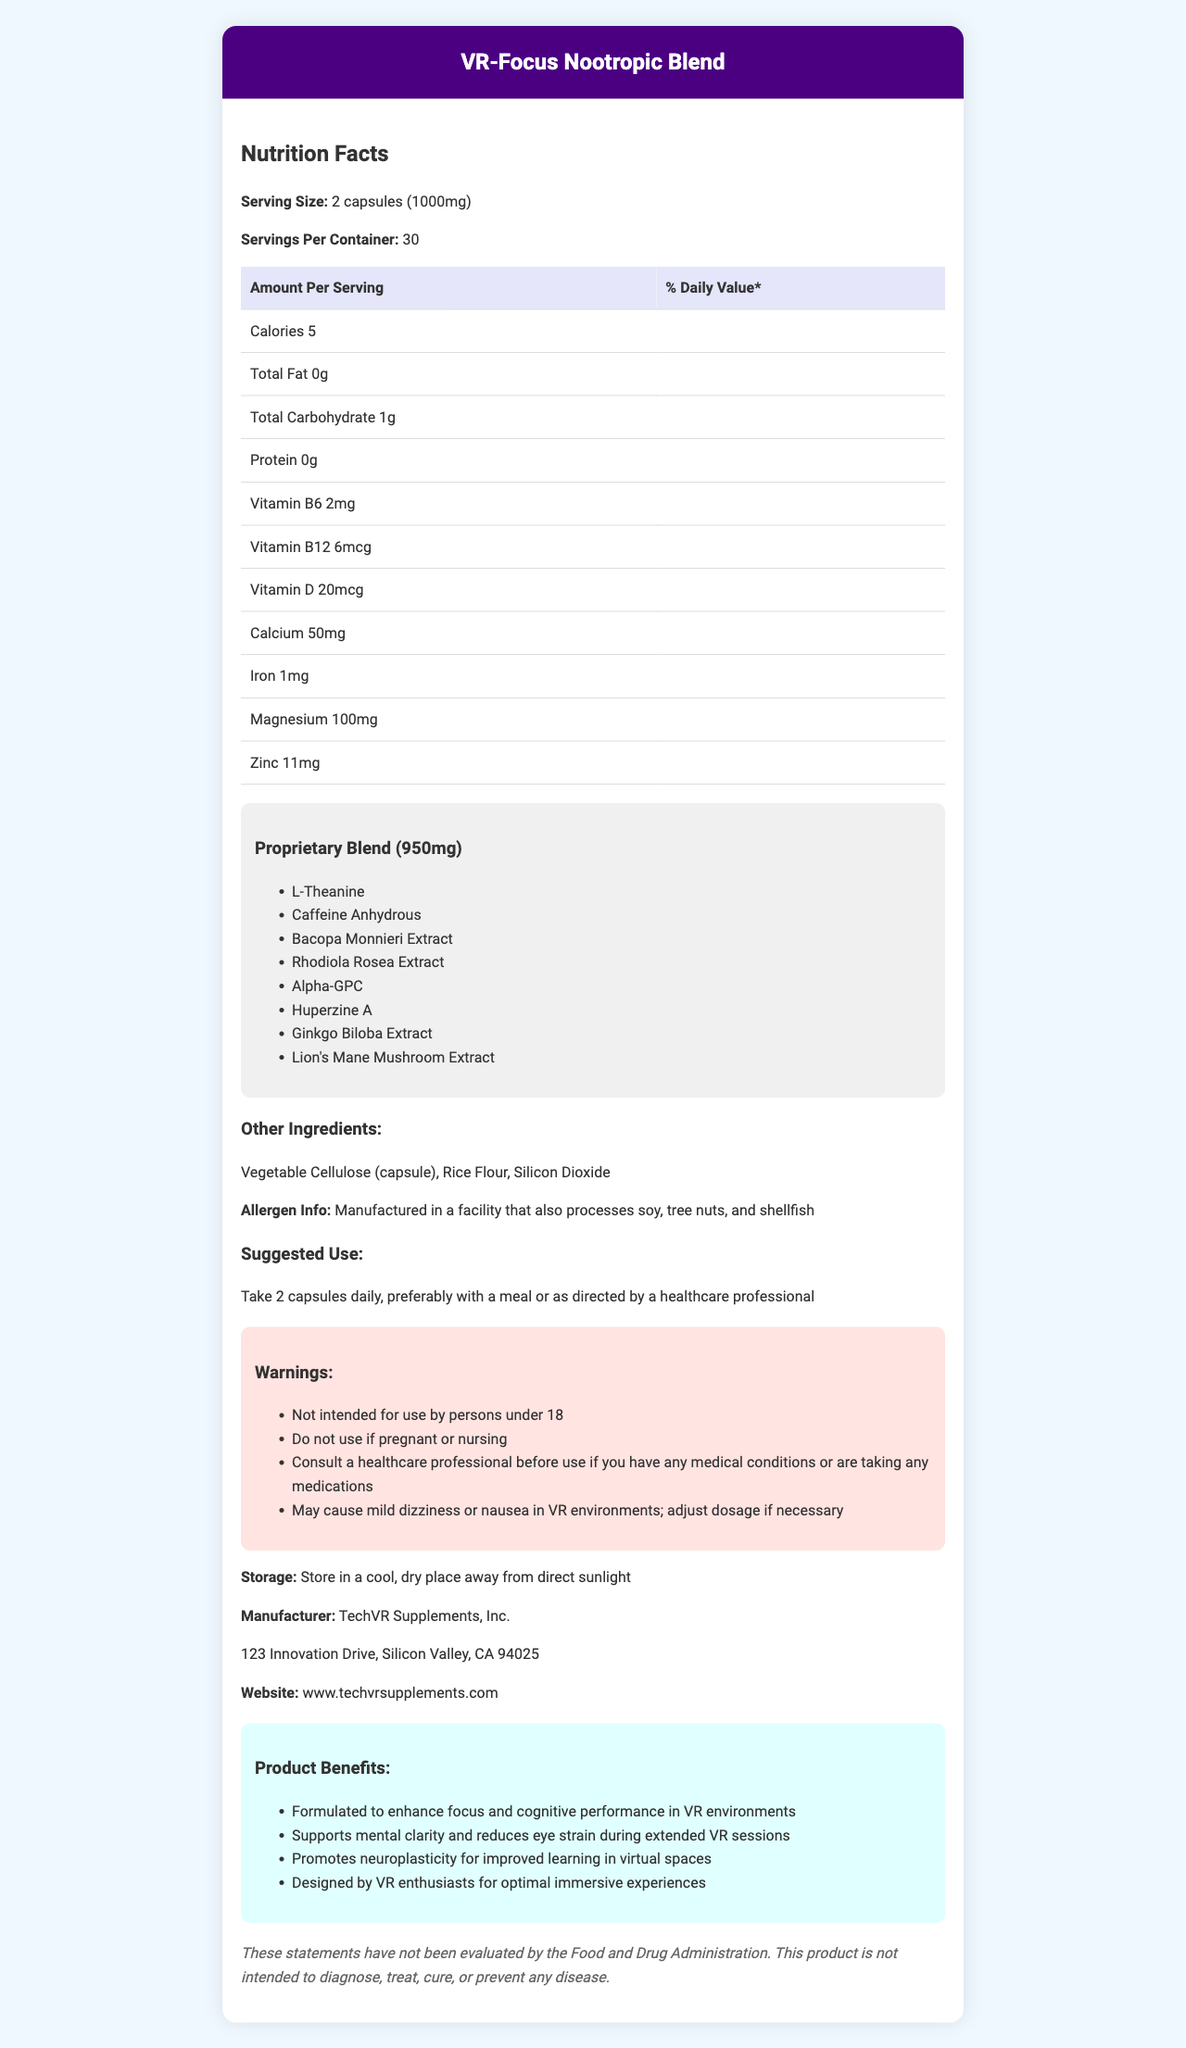What is the serving size for VR-Focus Nootropic Blend? The serving size is clearly mentioned in the document as "2 capsules (1000mg)".
Answer: 2 capsules (1000mg) How many calories are in each serving? The document indicates that each serving contains 5 calories.
Answer: 5 calories What are the suggested use instructions for VR-Focus Nootropic Blend? The suggested use is stated in the document under "Suggested Use".
Answer: Take 2 capsules daily, preferably with a meal or as directed by a healthcare professional Which vitamins are included in the supplement? The document lists Vitamin B6, Vitamin B12, and Vitamin D in the nutrition facts.
Answer: Vitamin B6, Vitamin B12, Vitamin D How much magnesium is in each serving? The document specifies that there is 100mg of magnesium per serving.
Answer: 100mg Which of the following ingredients is NOT part of the proprietary blend? A. L-Theanine B. Rice Flour C. Alpha-GPC D. Bacopa Monnieri Extract The proprietary blend includes L-Theanine, Alpha-GPC, and Bacopa Monnieri Extract. Rice Flour is listed under "Other Ingredients".
Answer: B. Rice Flour What is the percentage daily value of zinc per serving, if the daily value for zinc is 11mg? A. 50% B. 75% C. 100% D. 200% The per serving amount of Zinc is 11mg, which is 100% of the daily value.
Answer: C. 100% Does the product contain any protein? The document shows "Protein: 0g", indicating there is no protein in the product.
Answer: No Is the product suitable for children under 18? The warning section states that the product is "Not intended for use by persons under 18".
Answer: No Summarize the main purpose and benefits of the VR-Focus Nootropic Blend. The document describes the product as specifically formulated to improve VR experiences by enhancing cognitive functions, reducing eye strain, and promoting neuroplasticity. It is designed by VR enthusiasts and includes a blend of nootropic ingredients.
Answer: The VR-Focus Nootropic Blend is designed to enhance focus and cognitive performance in virtual reality (VR) environments. It supports mental clarity, reduces eye strain during extended VR sessions, and promotes neuroplasticity for improved learning in virtual spaces. The product is formulated with a proprietary blend of ingredients known for their cognitive benefits. What ingredients are listed under the "Other Ingredients" category? The document lists these ingredients under "Other Ingredients".
Answer: Vegetable Cellulose (capsule), Rice Flour, Silicon Dioxide What side effects might occur in VR environments when using this supplement? The document mentions that the supplement "May cause mild dizziness or nausea in VR environments."
Answer: May cause mild dizziness or nausea Does the document indicate the exact amount of each ingredient in the proprietary blend? The document only provides the total weight of the proprietary blend (950mg) and lists the ingredients, but does not specify the exact amount of each ingredient.
Answer: No What is the storage recommendation for this product? The storage recommendation is stated in the document under "Storage".
Answer: Store in a cool, dry place away from direct sunlight Who is the manufacturer of the VR-Focus Nootropic Blend? The document indicates that the manufacturer is TechVR Supplements, Inc.
Answer: TechVR Supplements, Inc. 